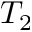Convert formula to latex. <formula><loc_0><loc_0><loc_500><loc_500>T _ { 2 }</formula> 